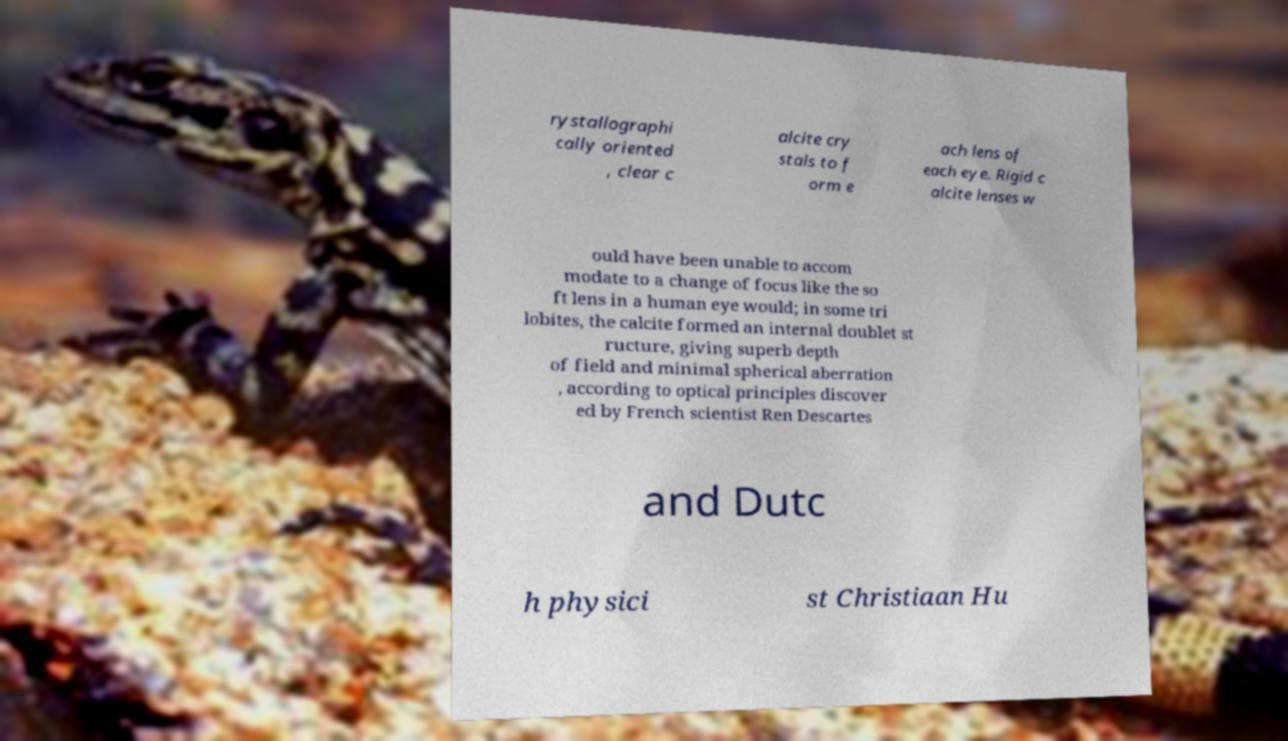What messages or text are displayed in this image? I need them in a readable, typed format. rystallographi cally oriented , clear c alcite cry stals to f orm e ach lens of each eye. Rigid c alcite lenses w ould have been unable to accom modate to a change of focus like the so ft lens in a human eye would; in some tri lobites, the calcite formed an internal doublet st ructure, giving superb depth of field and minimal spherical aberration , according to optical principles discover ed by French scientist Ren Descartes and Dutc h physici st Christiaan Hu 